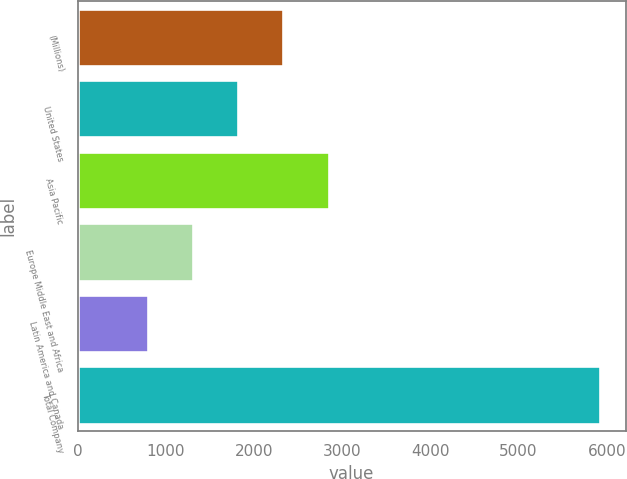Convert chart to OTSL. <chart><loc_0><loc_0><loc_500><loc_500><bar_chart><fcel>(Millions)<fcel>United States<fcel>Asia Pacific<fcel>Europe Middle East and Africa<fcel>Latin America and Canada<fcel>Total Company<nl><fcel>2333.3<fcel>1821.2<fcel>2845.4<fcel>1309.1<fcel>797<fcel>5918<nl></chart> 